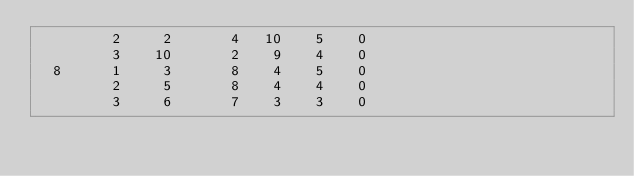<code> <loc_0><loc_0><loc_500><loc_500><_ObjectiveC_>         2     2       4   10    5    0
         3    10       2    9    4    0
  8      1     3       8    4    5    0
         2     5       8    4    4    0
         3     6       7    3    3    0</code> 